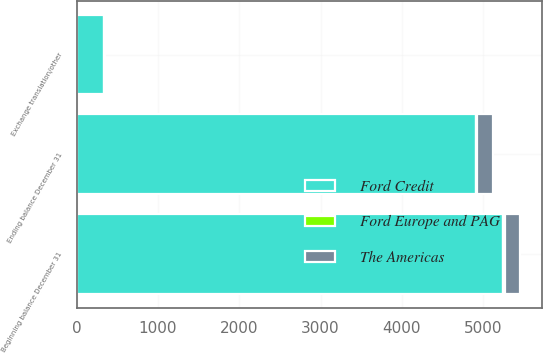Convert chart. <chart><loc_0><loc_0><loc_500><loc_500><stacked_bar_chart><ecel><fcel>Beginning balance December 31<fcel>Exchange translation/other<fcel>Ending balance December 31<nl><fcel>The Americas<fcel>188<fcel>7<fcel>202<nl><fcel>Ford Credit<fcel>5248<fcel>342<fcel>4906<nl><fcel>Ford Europe and PAG<fcel>20<fcel>3<fcel>17<nl></chart> 